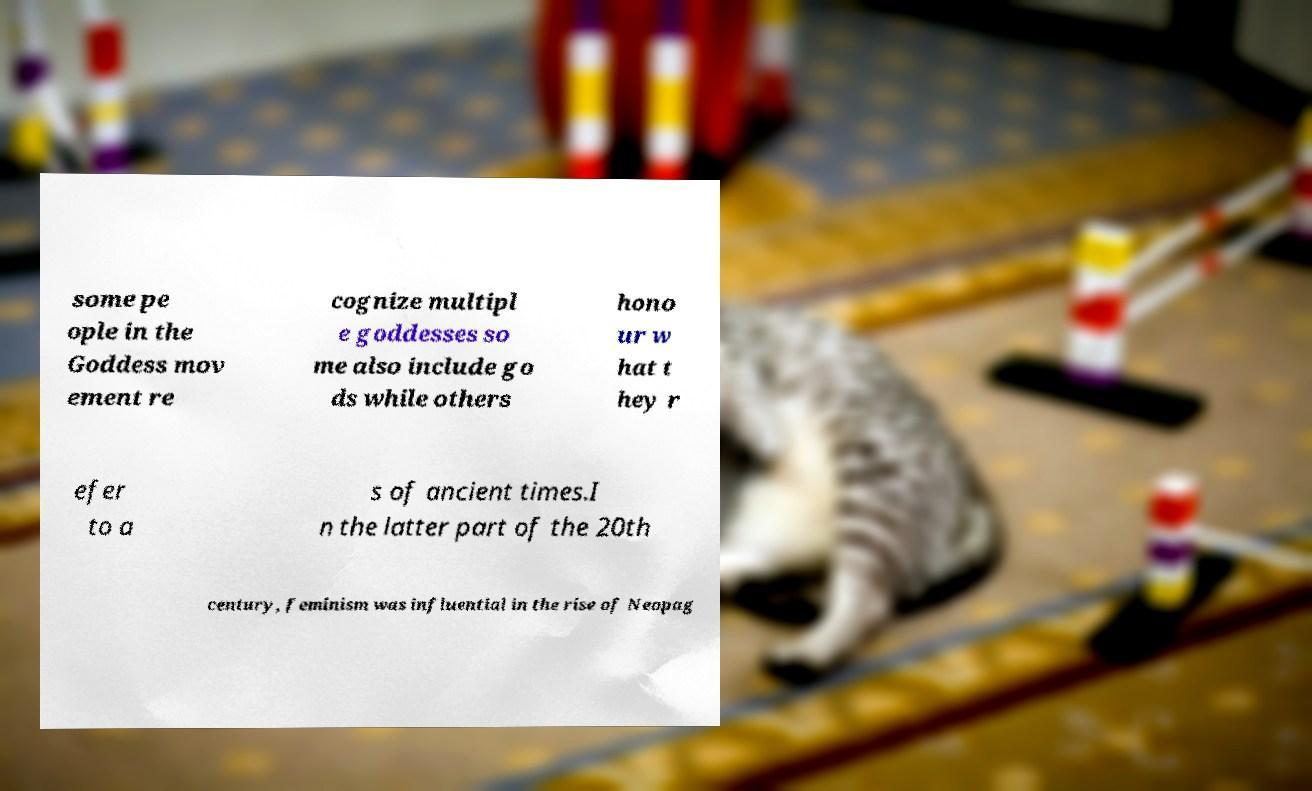Could you extract and type out the text from this image? some pe ople in the Goddess mov ement re cognize multipl e goddesses so me also include go ds while others hono ur w hat t hey r efer to a s of ancient times.I n the latter part of the 20th century, feminism was influential in the rise of Neopag 